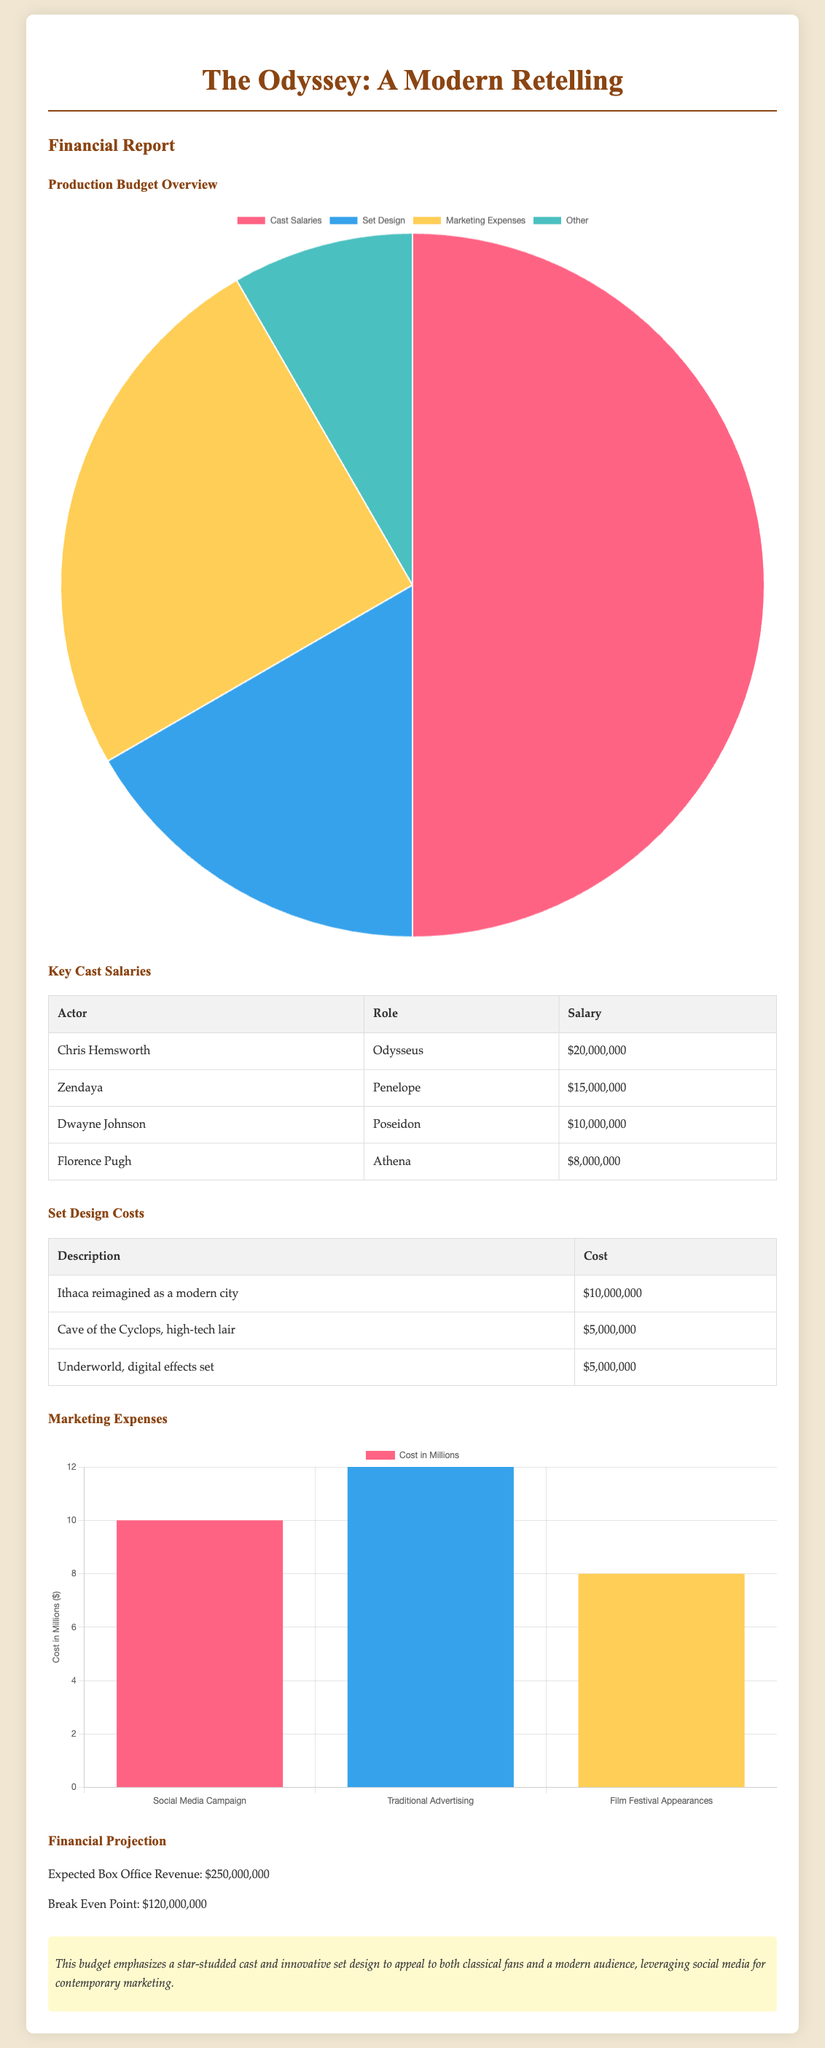What is the total cast salary? The total cast salary is the sum of all individual actor salaries presented in the document: $20,000,000 + $15,000,000 + $10,000,000 + $8,000,000 = $53,000,000.
Answer: $53,000,000 What is the set design cost for Ithaca? The document specifies the cost for reimagining Ithaca as a modern city as $10,000,000.
Answer: $10,000,000 Who plays the role of Penelope? The document lists Zendaya as the actress for the role of Penelope.
Answer: Zendaya What is the expected box office revenue? The document states that the expected box office revenue is $250,000,000.
Answer: $250,000,000 What percentage of the production budget is allocated to marketing expenses? The marketing expenses listed is $30,000,000, of a total budget of $100,000,000, resulting in 30% allocated to marketing.
Answer: 30% What is the cost for the Cave of the Cyclops? The document mentions that the cost for the Cave of the Cyclops, high-tech lair is $5,000,000.
Answer: $5,000,000 How much is spent on traditional advertising? According to the marketing expenses breakdown, $12,000,000 is spent on traditional advertising.
Answer: $12,000,000 What role does Dwayne Johnson play? The document indicates that Dwayne Johnson plays the role of Poseidon.
Answer: Poseidon 